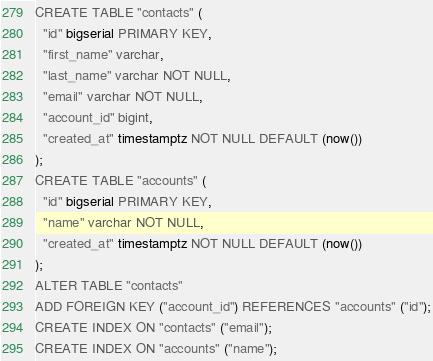<code> <loc_0><loc_0><loc_500><loc_500><_SQL_>CREATE TABLE "contacts" (
  "id" bigserial PRIMARY KEY,
  "first_name" varchar,
  "last_name" varchar NOT NULL,
  "email" varchar NOT NULL,
  "account_id" bigint,
  "created_at" timestamptz NOT NULL DEFAULT (now())
);
CREATE TABLE "accounts" (
  "id" bigserial PRIMARY KEY,
  "name" varchar NOT NULL,
  "created_at" timestamptz NOT NULL DEFAULT (now())
);
ALTER TABLE "contacts"
ADD FOREIGN KEY ("account_id") REFERENCES "accounts" ("id");
CREATE INDEX ON "contacts" ("email");
CREATE INDEX ON "accounts" ("name");</code> 